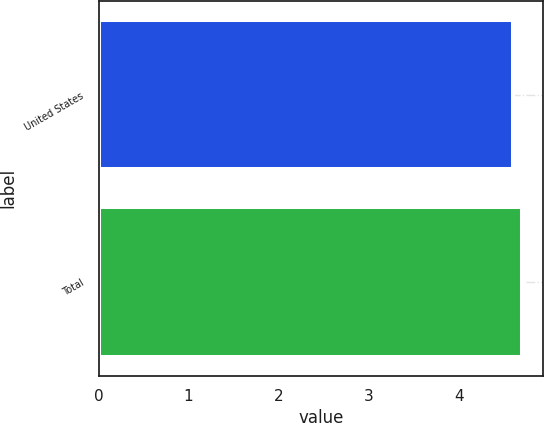<chart> <loc_0><loc_0><loc_500><loc_500><bar_chart><fcel>United States<fcel>Total<nl><fcel>4.6<fcel>4.7<nl></chart> 